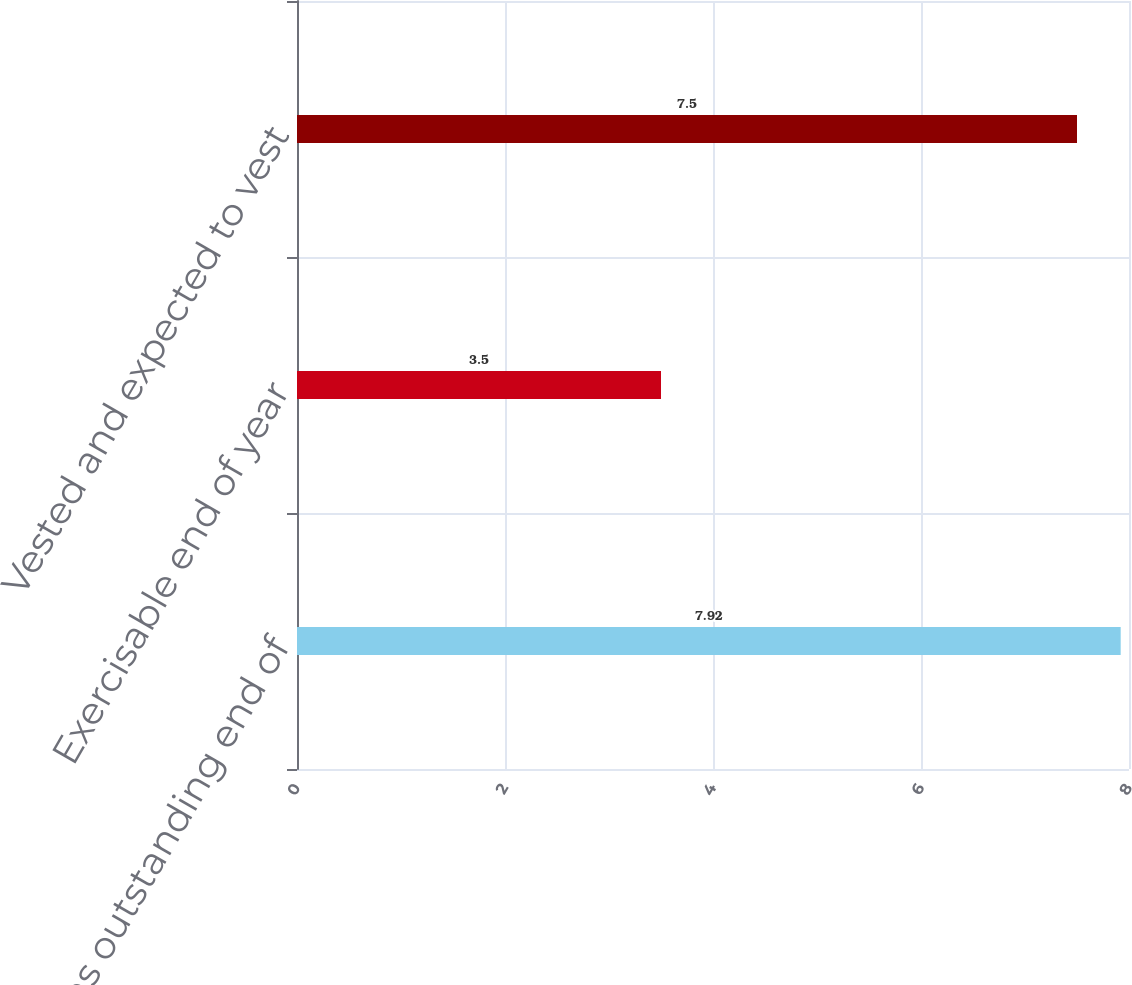Convert chart to OTSL. <chart><loc_0><loc_0><loc_500><loc_500><bar_chart><fcel>Options outstanding end of<fcel>Exercisable end of year<fcel>Vested and expected to vest<nl><fcel>7.92<fcel>3.5<fcel>7.5<nl></chart> 